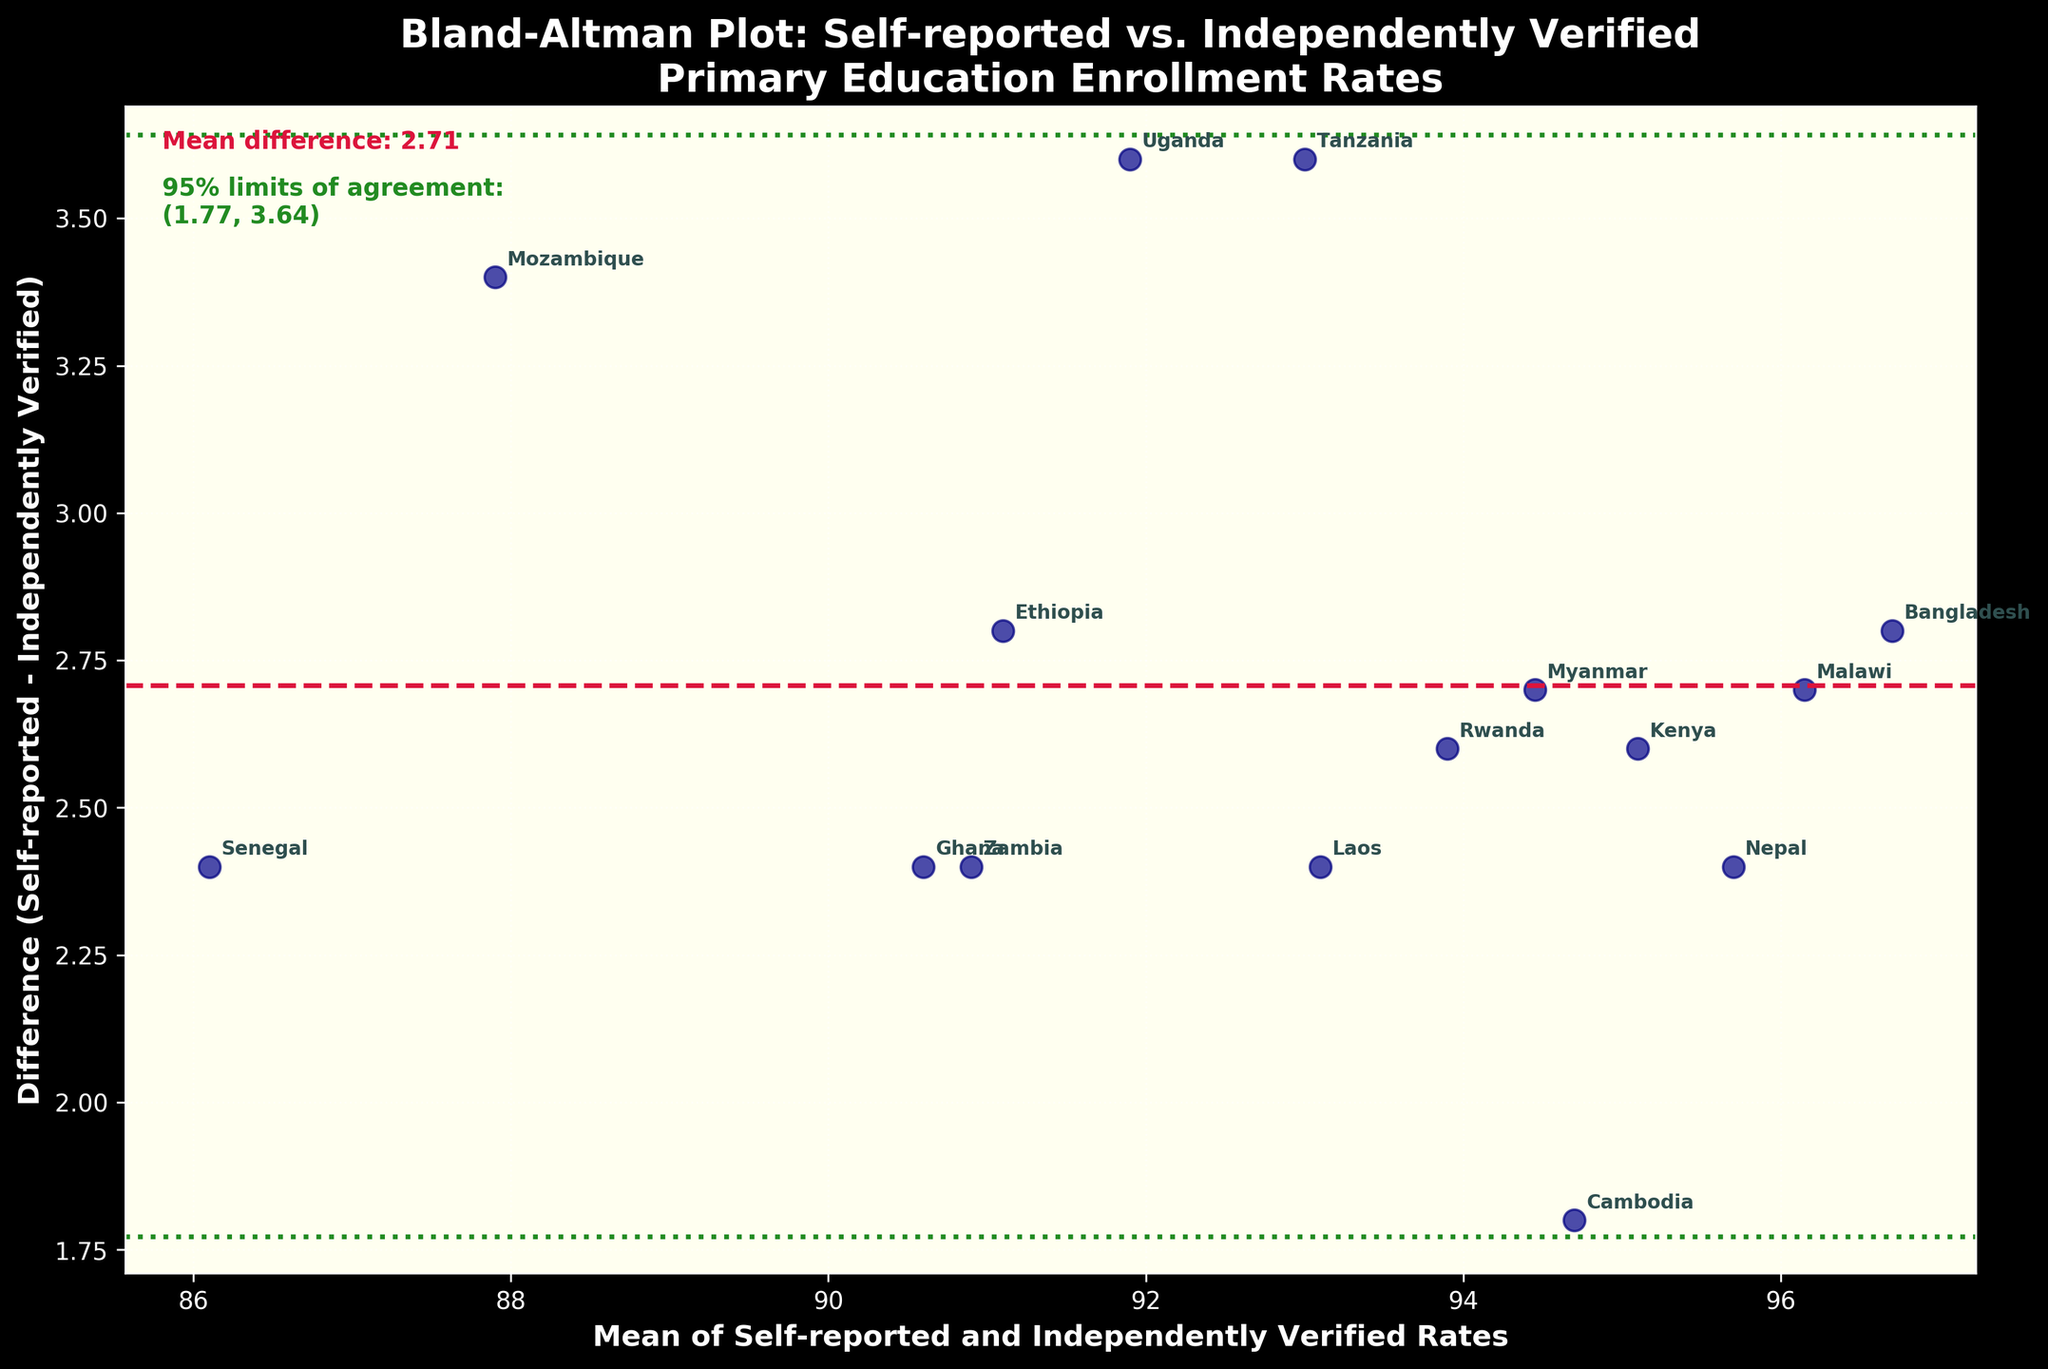What is the title of the figure? The title is usually provided at the top center of the plot. In this case, it reads "Bland-Altman Plot: Self-reported vs. Independently Verified Primary Education Enrollment Rates".
Answer: Bland-Altman Plot: Self-reported vs. Independently Verified Primary Education Enrollment Rates How many countries are represented in the plot? The number of countries is indicated by the number of scatter points and annotations on the plot. Counting them gives us the total.
Answer: 15 Which country has the largest positive difference between self-reported and independently verified enrollment rates? Locate the point that is highest above the zero line on the difference axis. The annotation shows the country name.
Answer: Bangladesh What is the mean difference between self-reported and independently verified enrollment rates? The mean difference is displayed as a labeled horizontal crimson dashed line on the plot. The text on the figure mentions it.
Answer: 2.63 Which country has the smallest mean of self-reported and independently verified enrollment rates? Find the point closest to the left on the mean axis. The annotation shows the country name.
Answer: Senegal What are the 95% limits of agreement presented on the plot? The 95% limits of agreement are displayed as two horizontal green dotted lines above and below the mean difference line. The text on the figure provides the exact values.
Answer: (-0.13, 5.39) Is there more than one country where the self-reported rate is lower than the independently verified rate? Identify points below the zero line on the difference axis. Count the number of such points to determine.
Answer: No Which country has the smallest negative difference between self-reported and independently verified enrollment rates? Locate the point nearest and below the zero line on the difference axis. The annotation shows the country name.
Answer: Mozambique Which country has the closest mean enrollment rate to 95%? Find the point closest to 95 on the X-axis (mean axis). The annotation shows the country name.
Answer: Laos How many countries are within the 95% limits of agreement? Count the number of points that fall between the upper and lower 95% limits of agreement lines on the difference axis.
Answer: 15 